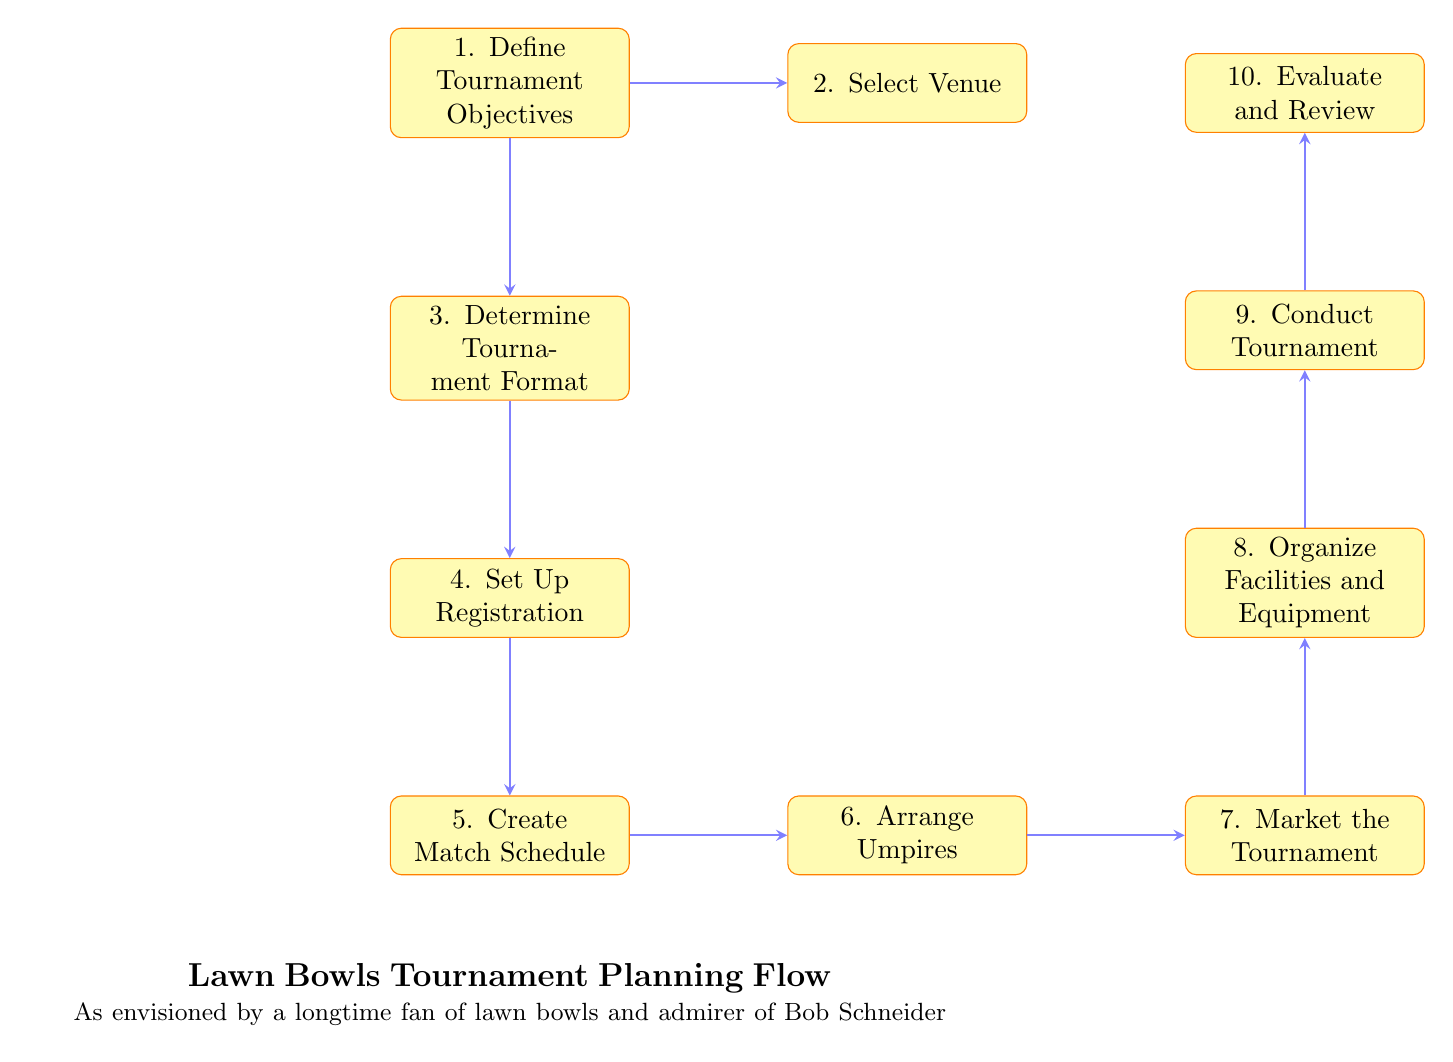What is the first step in the tournament planning process? The first step according to the diagram is labeled as "1. Define Tournament Objectives," which is indicated as the initial node in the flow chart.
Answer: Define Tournament Objectives How many nodes are there in the diagram? To find the total number of nodes, we count each distinct process presented in the flow chart, which totals 10 unique nodes.
Answer: 10 Which node directly follows 'Set Up Registration'? The diagram indicates that "5. Create Match Schedule" is the next process that follows "4. Set Up Registration," connecting them directly.
Answer: Create Match Schedule What is the last step in the tournament planning process? The final step is indicated as "10. Evaluate and Review," which is the last node after all preceding processes are completed.
Answer: Evaluate and Review Which two nodes are connected at step 6? In step 6, the nodes "6. Arrange Umpires" and "7. Market the Tournament" are directly connected, showing the flow from arranging officials to promoting the event.
Answer: Arrange Umpires and Market the Tournament If the tournament format is determined, what is the next action? After determining the tournament format, the diagram specifies that the next action is "4. Set Up Registration," establishing the need for participant registration immediately after format decision.
Answer: Set Up Registration What is a possible venue according to the flow chart? The chart suggests choosing a venue like 'St. Ives Bowling Club' or 'Mona Vale Bowling Club,' as examples provided along the process.
Answer: St. Ives Bowling Club or Mona Vale Bowling Club What is the connection between 'Market the Tournament' and 'Conduct Tournament'? The connection shows that after marketing efforts in step 7, it leads directly to step 9, "Conduct Tournament," indicating that marketing supports the execution phase.
Answer: Market the Tournament leads to Conduct Tournament 